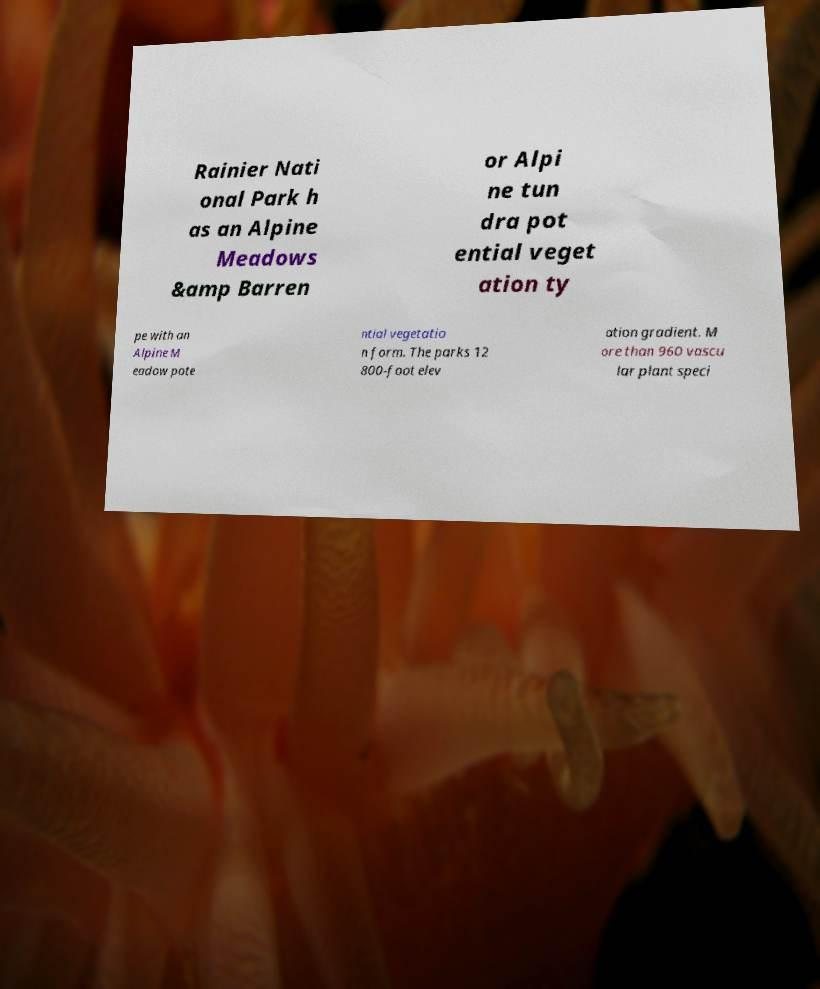For documentation purposes, I need the text within this image transcribed. Could you provide that? Rainier Nati onal Park h as an Alpine Meadows &amp Barren or Alpi ne tun dra pot ential veget ation ty pe with an Alpine M eadow pote ntial vegetatio n form. The parks 12 800-foot elev ation gradient. M ore than 960 vascu lar plant speci 